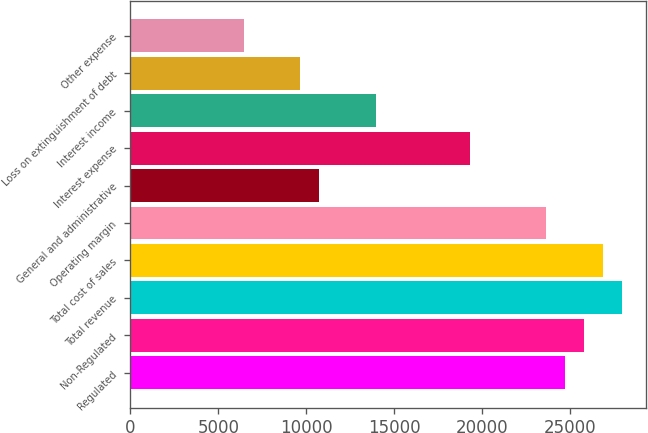<chart> <loc_0><loc_0><loc_500><loc_500><bar_chart><fcel>Regulated<fcel>Non-Regulated<fcel>Total revenue<fcel>Total cost of sales<fcel>Operating margin<fcel>General and administrative<fcel>Interest expense<fcel>Interest income<fcel>Loss on extinguishment of debt<fcel>Other expense<nl><fcel>24692.4<fcel>25766<fcel>27913.2<fcel>26839.6<fcel>23618.9<fcel>10736<fcel>19324.6<fcel>13956.7<fcel>9662.46<fcel>6441.75<nl></chart> 